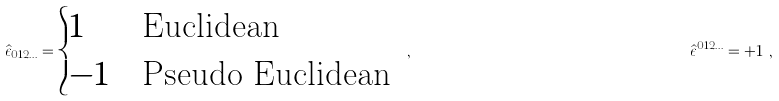Convert formula to latex. <formula><loc_0><loc_0><loc_500><loc_500>\hat { \epsilon } _ { 0 1 2 \dots } = \begin{cases} 1 & \text {Euclidean} \\ - 1 & \text {Pseudo Euclidean} \end{cases} \ , & & \hat { \epsilon } ^ { 0 1 2 \dots } = + 1 \ ,</formula> 